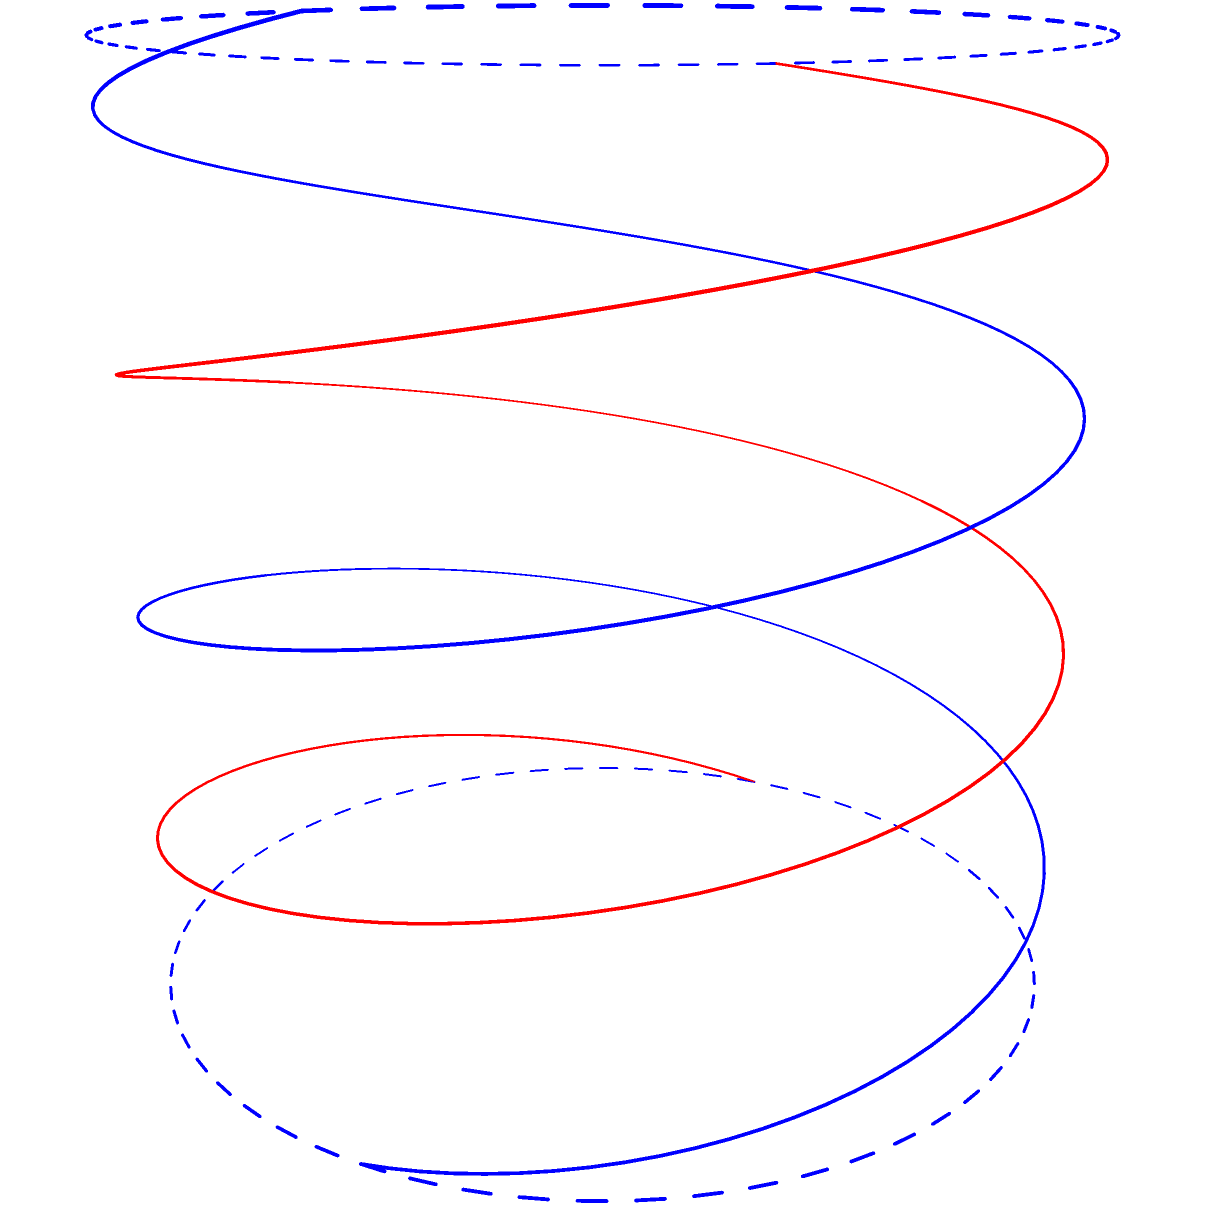Consider the DNA double helix structure shown in the figure. If the structure is rotated 180° around its central axis, what is the minimum height (in terms of π) at which the rotated structure will exactly match its original position? To solve this problem, we need to understand the concept of rotational symmetry in a DNA double helix:

1. The DNA double helix consists of two intertwined helices.
2. Each complete turn of a single helix corresponds to a height of 2π.
3. The two helices are offset by 180° (π radians) from each other.

Now, let's analyze the rotational symmetry:

1. A 180° rotation is equivalent to a π radian rotation.
2. For the structure to match its original position after a 180° rotation, we need to consider both helices:
   - One helix must complete a half-turn (π radians in height)
   - The other helix must complete a full turn (2π radians in height)

3. The minimum height at which both conditions are satisfied simultaneously is when:
   - The blue helix completes a half-turn: π
   - The red helix completes a full turn: 2π

4. These conditions are met at a height of 2π, which is the least common multiple of π and 2π.

Therefore, the minimum height at which the rotated structure will exactly match its original position is 2π.
Answer: 2π 